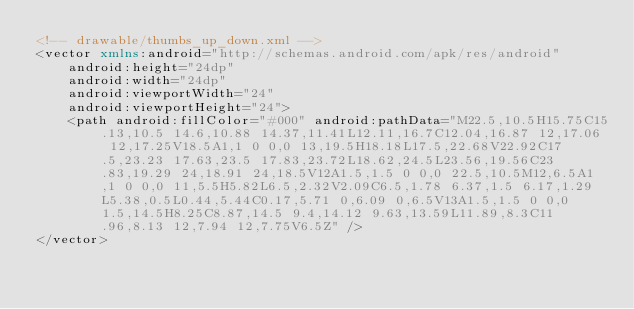Convert code to text. <code><loc_0><loc_0><loc_500><loc_500><_XML_><!-- drawable/thumbs_up_down.xml -->
<vector xmlns:android="http://schemas.android.com/apk/res/android"
    android:height="24dp"
    android:width="24dp"
    android:viewportWidth="24"
    android:viewportHeight="24">
    <path android:fillColor="#000" android:pathData="M22.5,10.5H15.75C15.13,10.5 14.6,10.88 14.37,11.41L12.11,16.7C12.04,16.87 12,17.06 12,17.25V18.5A1,1 0 0,0 13,19.5H18.18L17.5,22.68V22.92C17.5,23.23 17.63,23.5 17.83,23.72L18.62,24.5L23.56,19.56C23.83,19.29 24,18.91 24,18.5V12A1.5,1.5 0 0,0 22.5,10.5M12,6.5A1,1 0 0,0 11,5.5H5.82L6.5,2.32V2.09C6.5,1.78 6.37,1.5 6.17,1.29L5.38,0.5L0.44,5.44C0.17,5.71 0,6.09 0,6.5V13A1.5,1.5 0 0,0 1.5,14.5H8.25C8.87,14.5 9.4,14.12 9.63,13.59L11.89,8.3C11.96,8.13 12,7.94 12,7.75V6.5Z" />
</vector></code> 